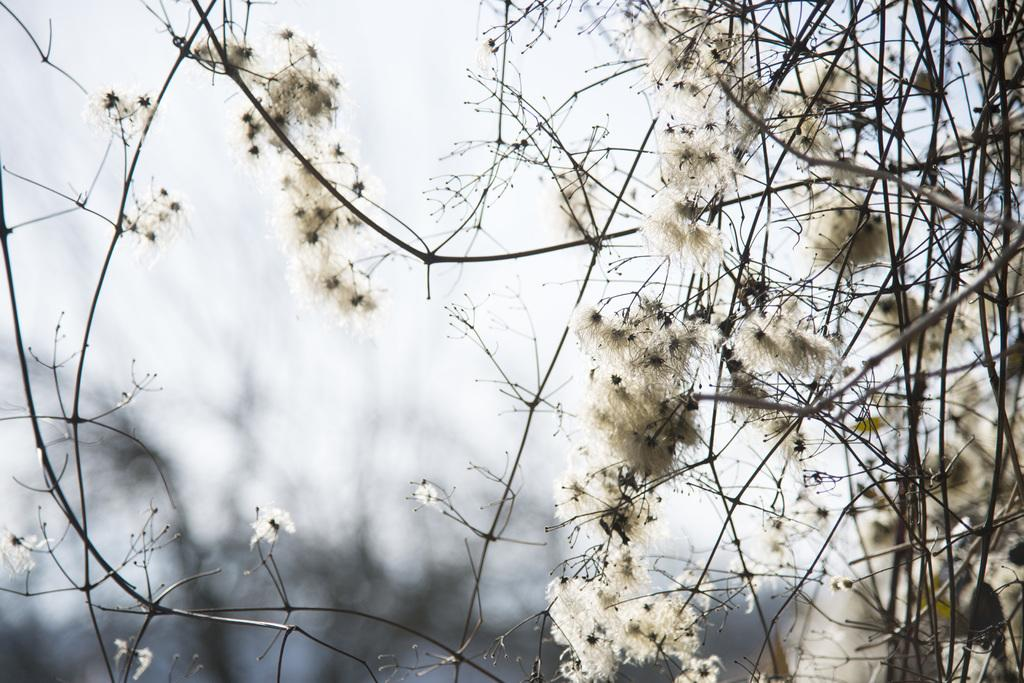What type of vegetation is present in the image? There are trees with flowers in the image. Can you describe the background of the image? The background of the image is blurred. What type of pump can be seen in the image? There is no pump present in the image; it features trees with flowers and a blurred background. What color is the chalk used by the person talking in the image? There is no person talking or using chalk in the image. 